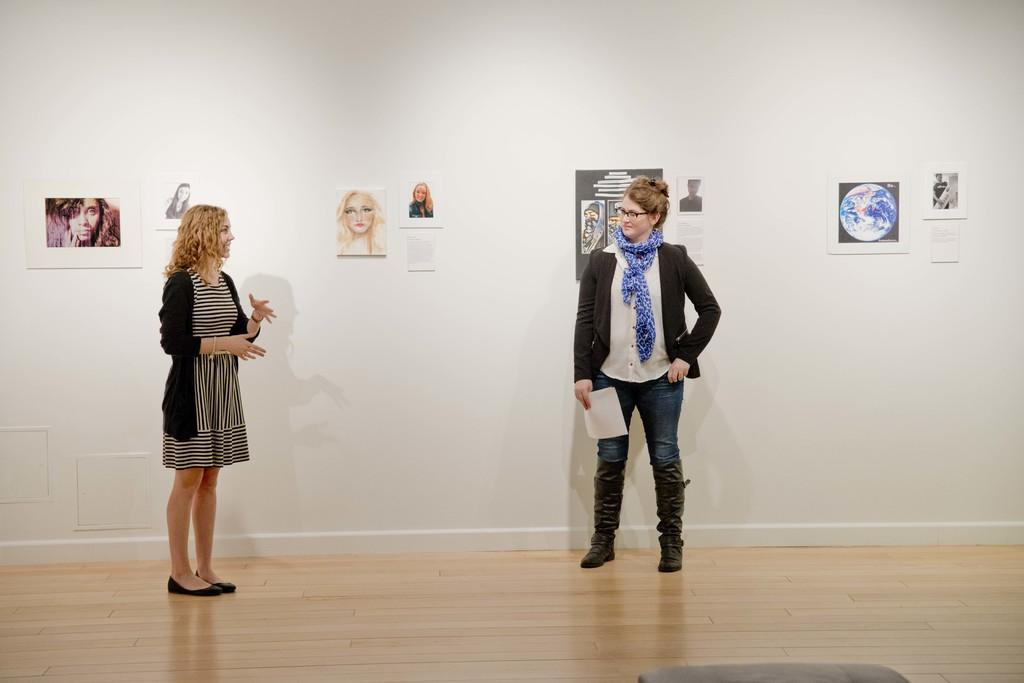How many people are in the image? There are two women in the image. What are the women doing in the image? The women are standing and talking with each other. What can be seen on the wall behind the women? There are pictures of people on the wall behind the women. What type of jelly can be seen on the dock in the image? There is no dock or jelly present in the image. What statement is being made by the women in the image? The image does not provide any information about the content of the conversation between the women, so it is impossible to determine what statement they might be making. 